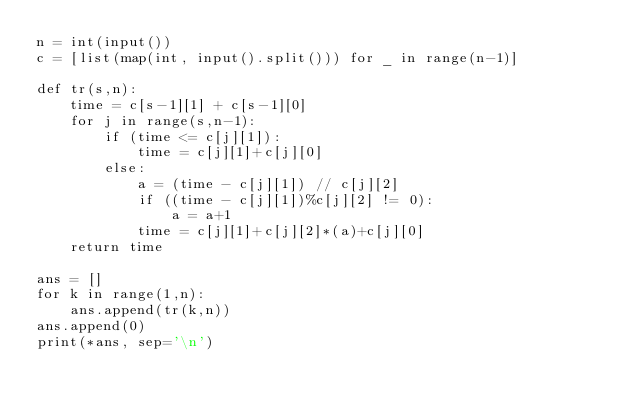<code> <loc_0><loc_0><loc_500><loc_500><_Python_>n = int(input())
c = [list(map(int, input().split())) for _ in range(n-1)]

def tr(s,n):
    time = c[s-1][1] + c[s-1][0]
    for j in range(s,n-1):
        if (time <= c[j][1]):
            time = c[j][1]+c[j][0]
        else:        
            a = (time - c[j][1]) // c[j][2]
            if ((time - c[j][1])%c[j][2] != 0):
                a = a+1
            time = c[j][1]+c[j][2]*(a)+c[j][0]
    return time

ans = []
for k in range(1,n):
    ans.append(tr(k,n))
ans.append(0)
print(*ans, sep='\n')</code> 